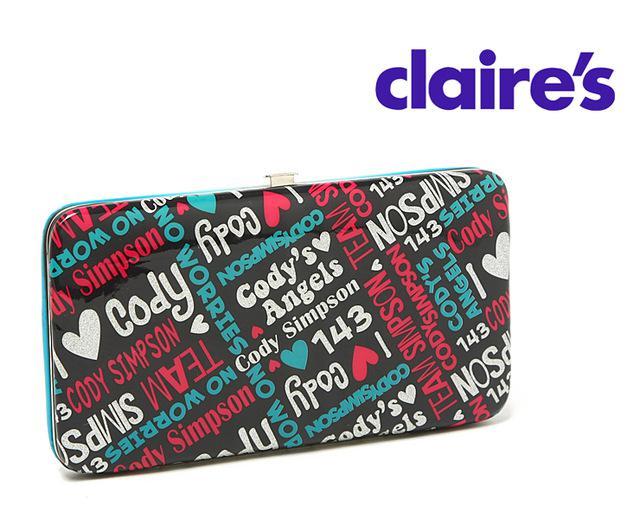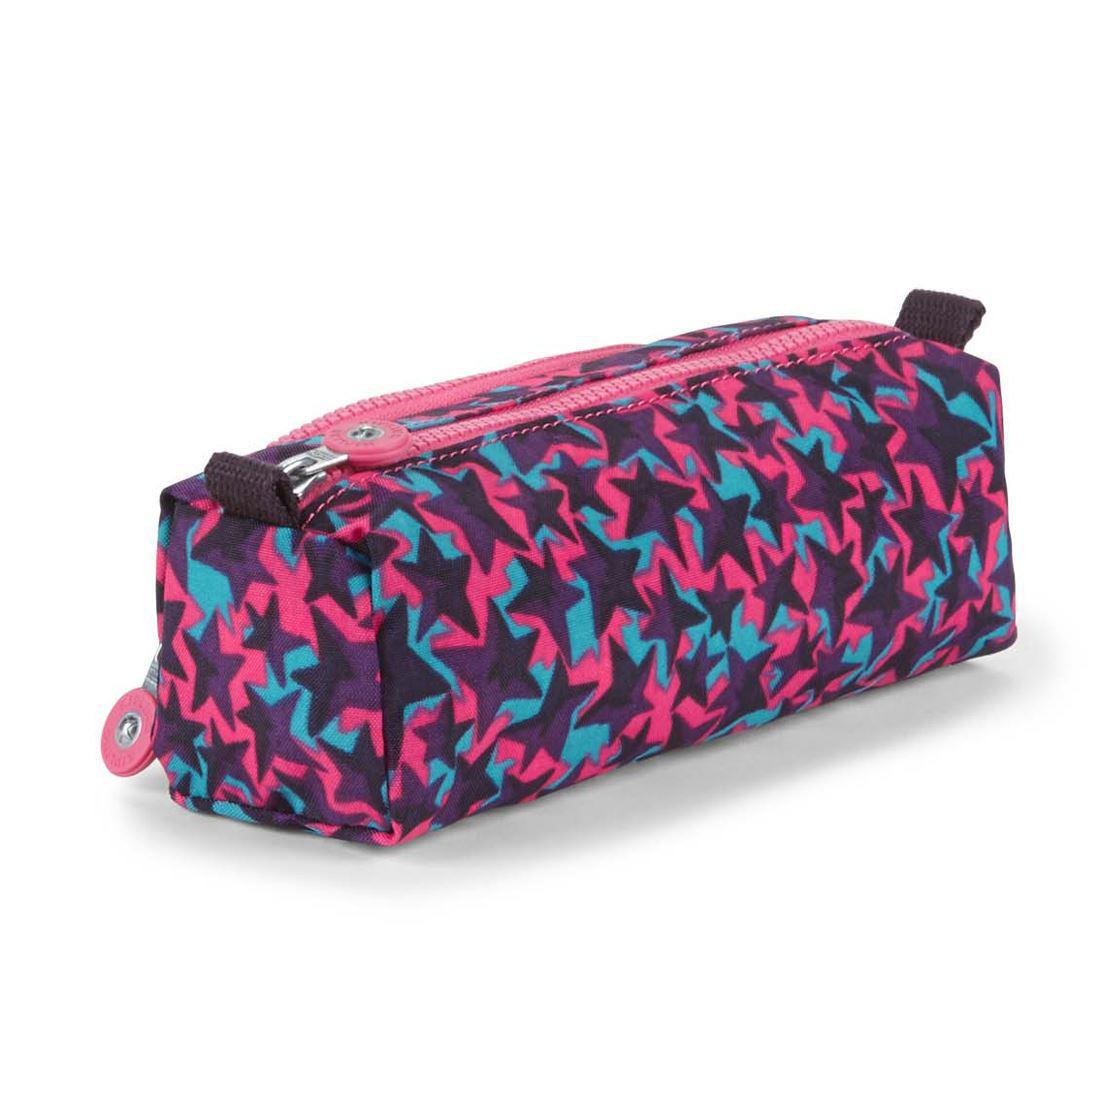The first image is the image on the left, the second image is the image on the right. Evaluate the accuracy of this statement regarding the images: "There are flowers on the case in the image on the left.". Is it true? Answer yes or no. No. 